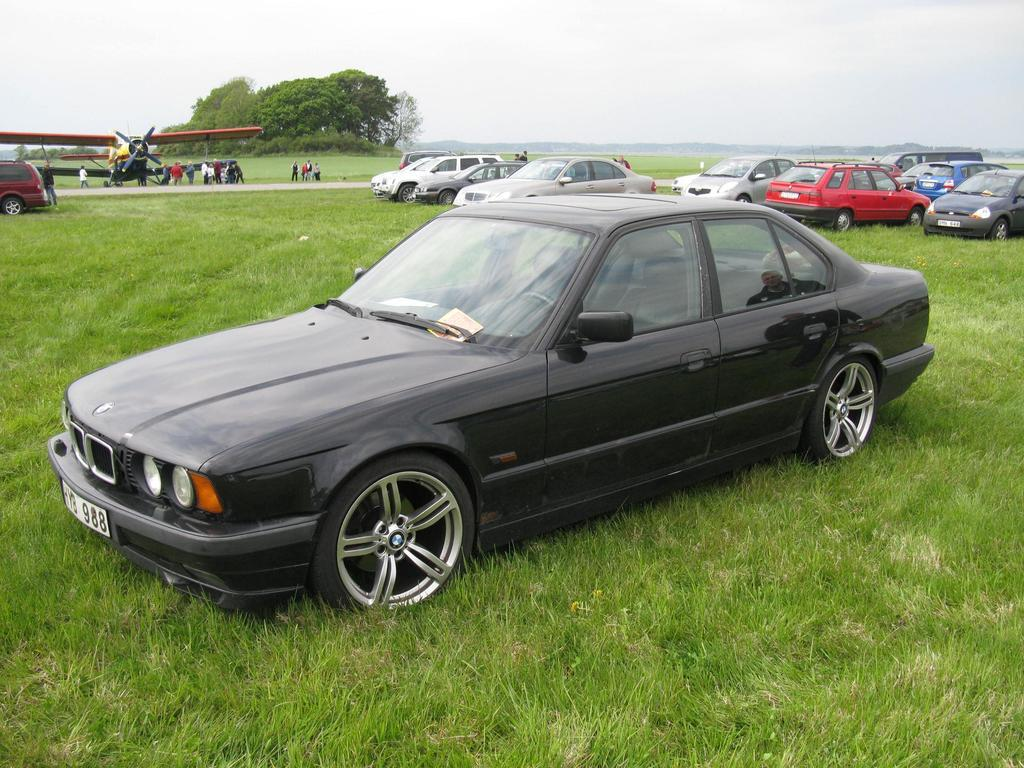What type of vehicles are on the grassy land in the image? There are cars on the grassy land in the image. What can be seen in the background of the image? There are trees, people, and an airplane in the background of the image. What is visible at the top of the image? The sky is visible at the top of the image. What can be observed in the sky? Clouds are present in the sky. What type of calculator can be seen in the image? There is no calculator present in the image. What type of shop can be seen in the image? There is no shop present in the image. 